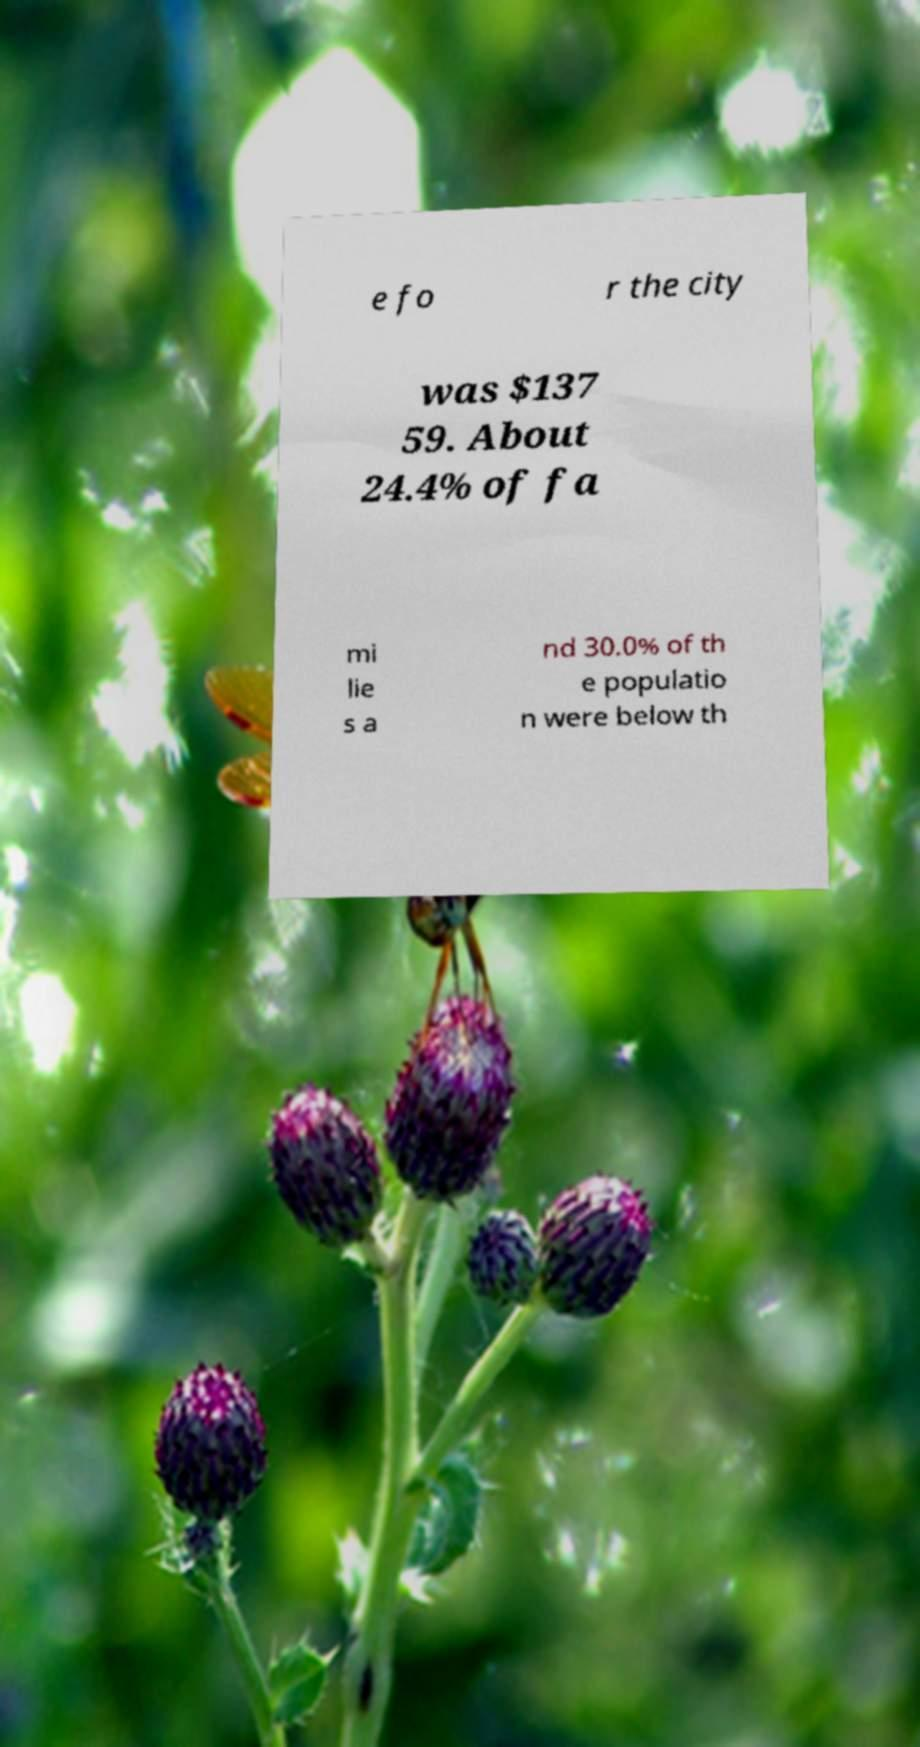Can you accurately transcribe the text from the provided image for me? e fo r the city was $137 59. About 24.4% of fa mi lie s a nd 30.0% of th e populatio n were below th 